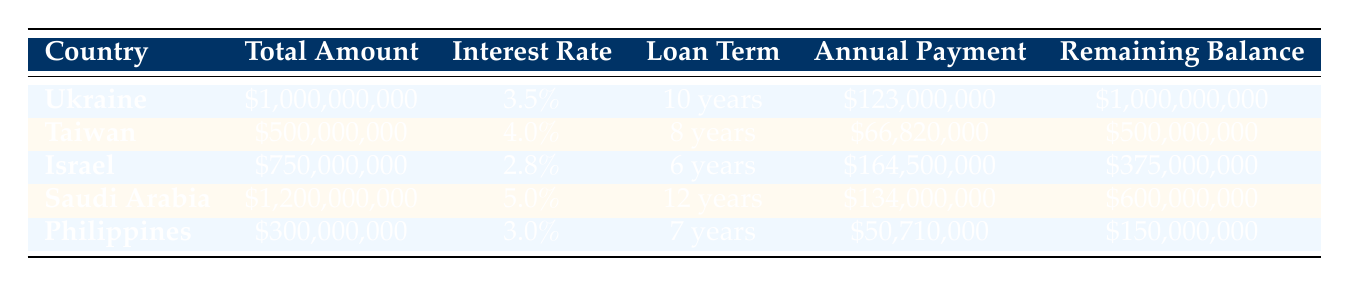What is the total amount of the contract with Taiwan? The total amount column for Taiwan's contract shows \$500,000,000.
Answer: 500000000 Which country has the highest interest rate on its military contract? Reviewing the interest rate column, Saudi Arabia has an interest rate of 5.0%, which is higher than the others listed.
Answer: Saudi Arabia What is the annual payment for the contract with Israel? The annual payment column indicates that Israel’s annual payment is \$164,500,000.
Answer: 164500000 How many years is the loan term for the Philippines' contract? The loan term for the Philippines is listed as 7 years in the loan term column.
Answer: 7 years What is the remaining balance for the contract with Ukraine? The remaining balance for Ukraine's contract shows \$1,000,000,000 in the remaining balance column.
Answer: 1000000000 Is the loan term for the contract with Saudi Arabia longer than that of the contract with Taiwan? Saudi Arabia's loan term is 12 years, while Taiwan's loan term is 8 years. Therefore, the loan term for Saudi Arabia is indeed longer than Taiwan's.
Answer: Yes What is the total of the annual payments for contracts with Ukraine and Israel? The annual payment for Ukraine is \$123,000,000 and for Israel it is \$164,500,000. Adding these two gives \$123,000,000 + \$164,500,000 = \$287,500,000.
Answer: 287500000 What percentage of the total amount of the contract with Taiwan remains unpaid? The remaining balance for Taiwan's contract is \$500,000,000, and since its total amount is also \$500,000,000, the unpaid percentage is (500000000/500000000)*100 = 100%.
Answer: 100% Which country has the smallest total amount for military contracts according to the table? The contract with the Philippines has the smallest total amount of \$300,000,000 compared to the other countries listed.
Answer: Philippines What is the difference in total amounts between the contracts with Saudi Arabia and the Philippines? Saudi Arabia's total amount is \$1,200,000,000 and the Philippines' is \$300,000,000. The difference is \$1,200,000,000 - \$300,000,000 = \$900,000,000.
Answer: 900000000 